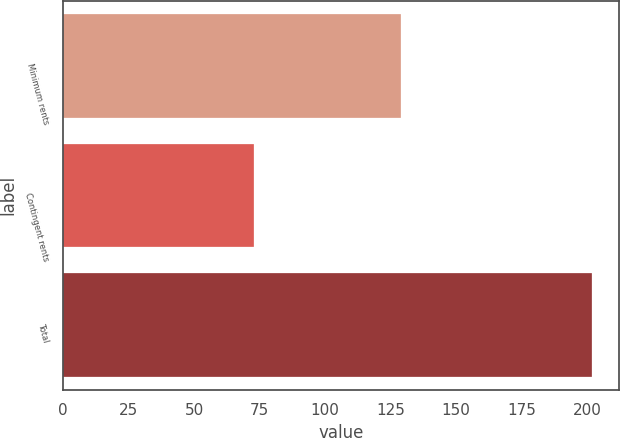Convert chart to OTSL. <chart><loc_0><loc_0><loc_500><loc_500><bar_chart><fcel>Minimum rents<fcel>Contingent rents<fcel>Total<nl><fcel>129<fcel>73<fcel>202<nl></chart> 